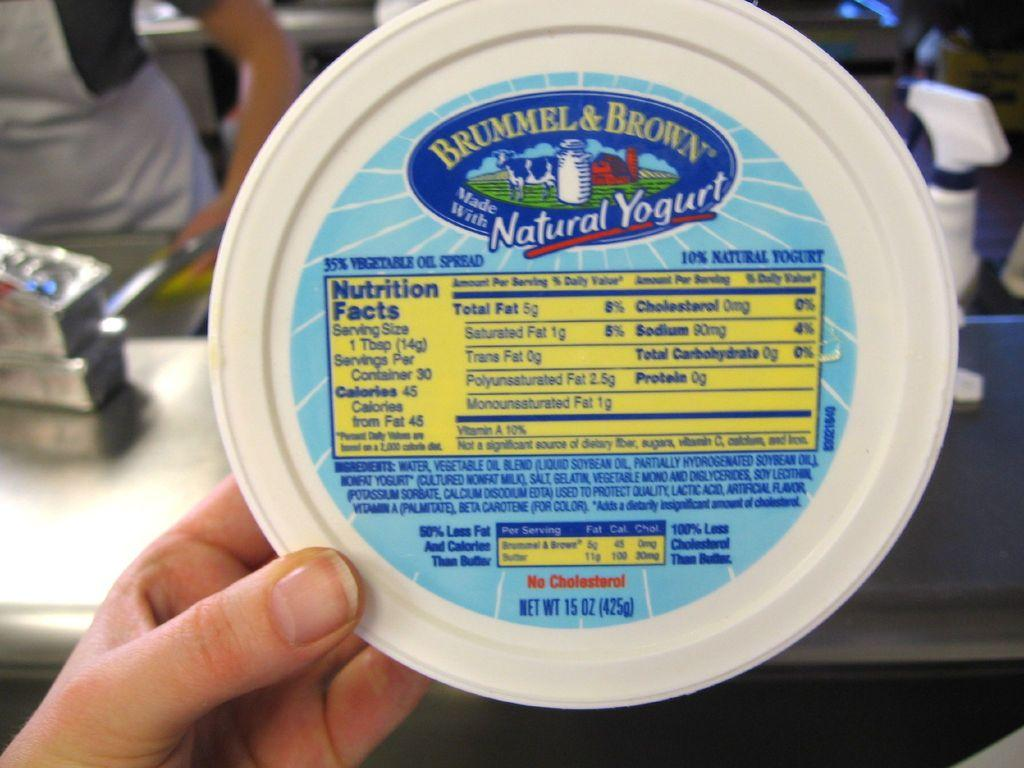What type of container is present in the image? There is a white color yogurt box in the image. Whose hand is visible in the image? A person's hand is visible in the image. What material is the table made of in the image? There is a steel table in the image. Can you describe the person in the background of the image? A woman is standing in the background of the image. What type of toothpaste is being used by the person in the image? There is no toothpaste present in the image; it features a yogurt box, a person's hand, a steel table, and a woman in the background. 